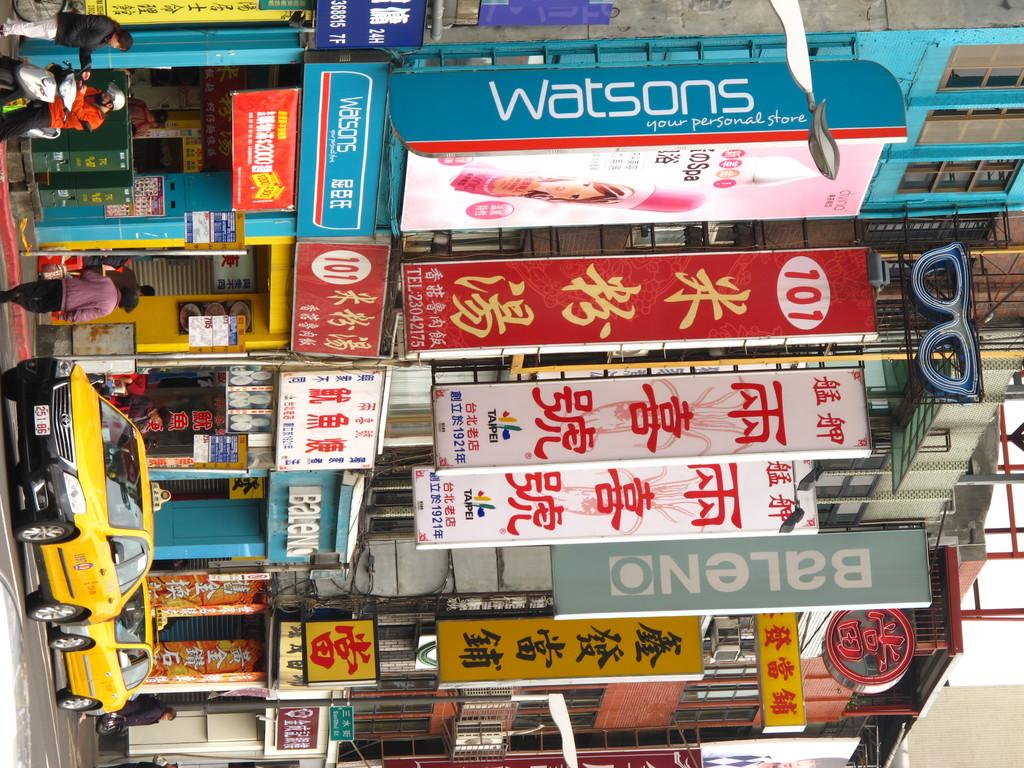<image>
Provide a brief description of the given image. a lot of signs, mostly written in chinese, and one that says watson, line the streets 